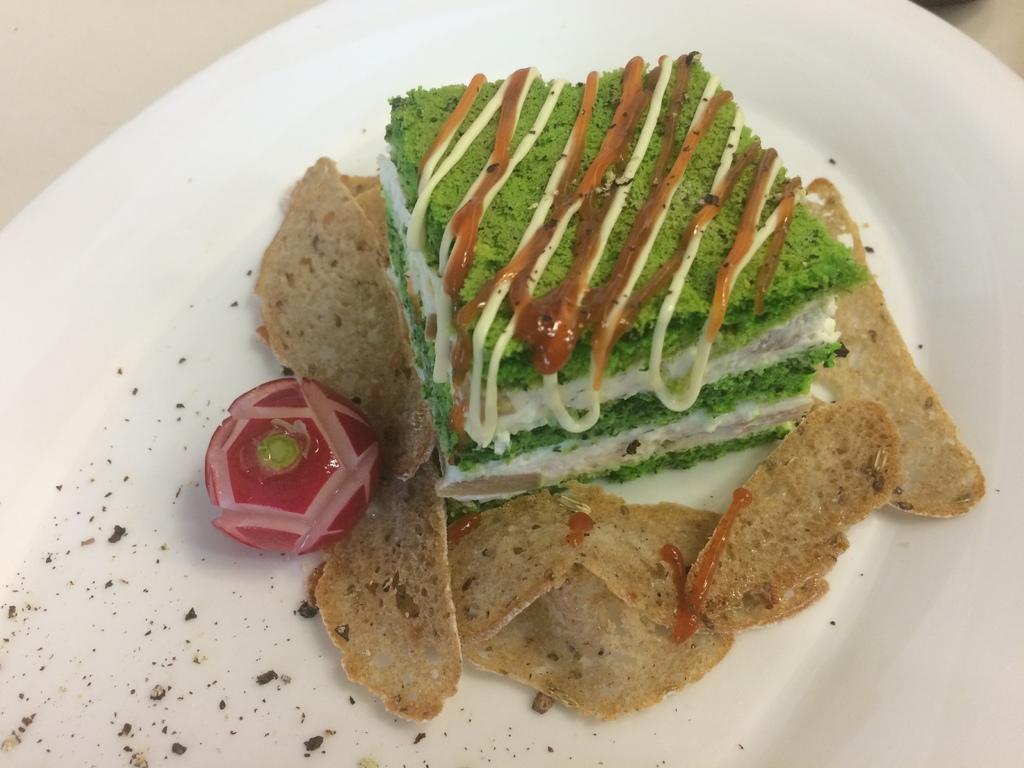Could you give a brief overview of what you see in this image? In this image there is food on the plate. Plate is kept on the white surface.   